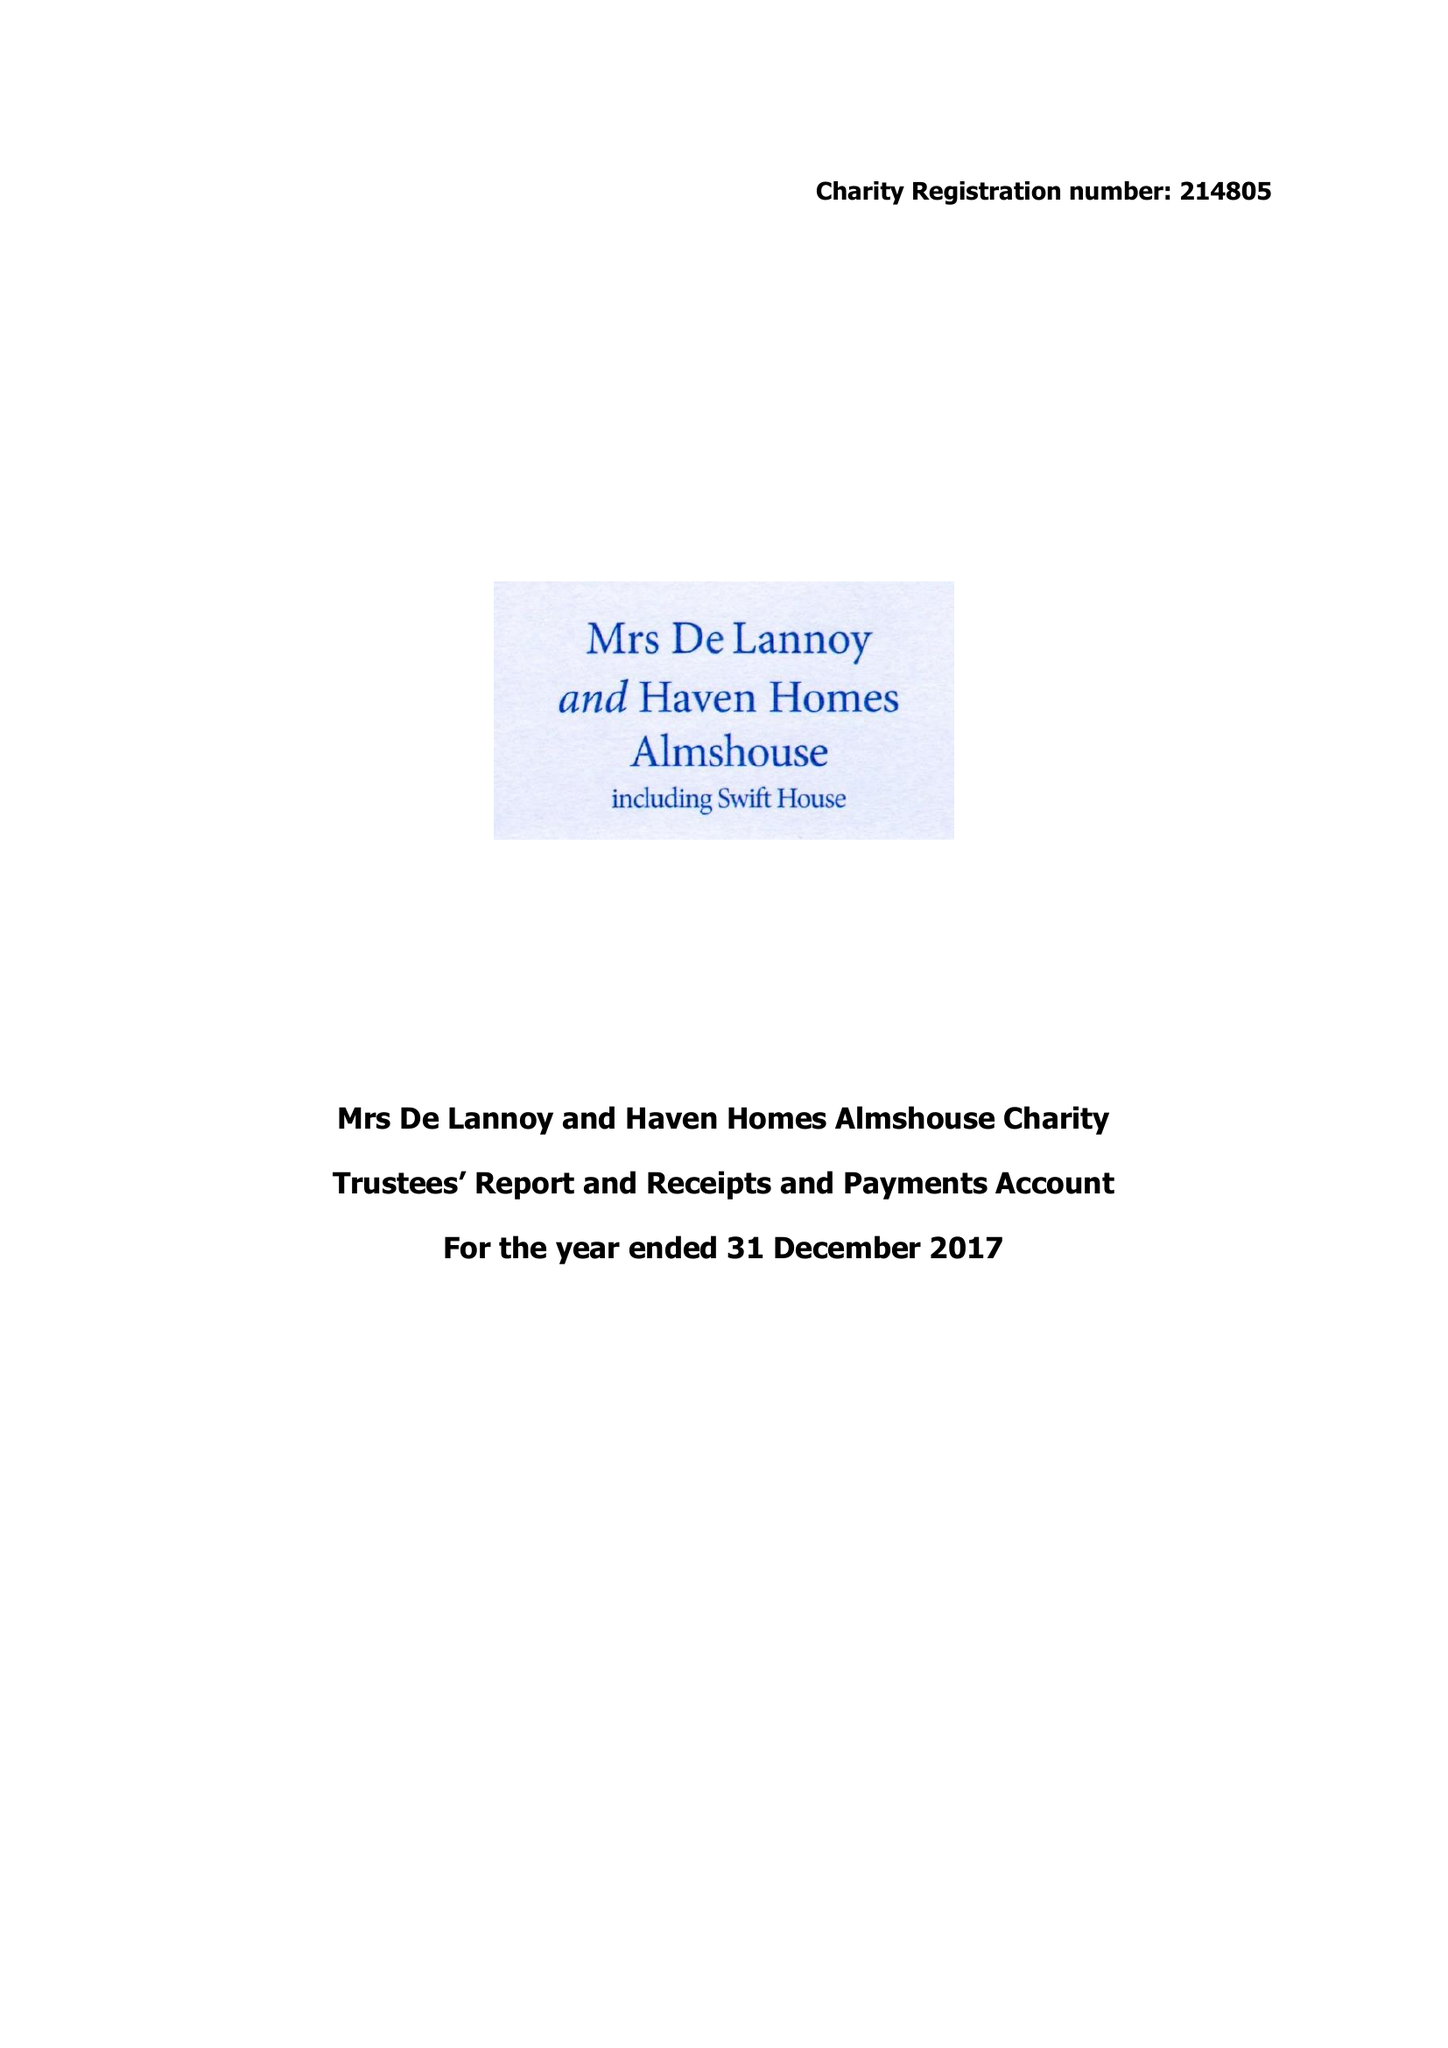What is the value for the report_date?
Answer the question using a single word or phrase. 2017-12-31 